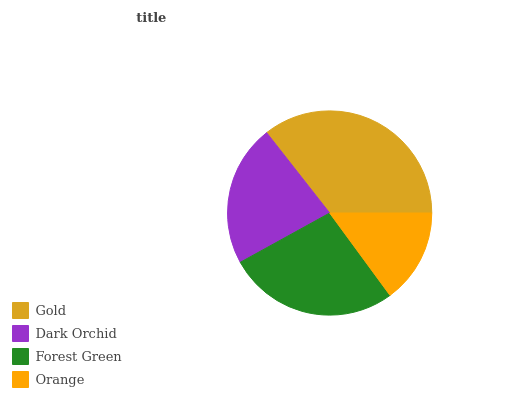Is Orange the minimum?
Answer yes or no. Yes. Is Gold the maximum?
Answer yes or no. Yes. Is Dark Orchid the minimum?
Answer yes or no. No. Is Dark Orchid the maximum?
Answer yes or no. No. Is Gold greater than Dark Orchid?
Answer yes or no. Yes. Is Dark Orchid less than Gold?
Answer yes or no. Yes. Is Dark Orchid greater than Gold?
Answer yes or no. No. Is Gold less than Dark Orchid?
Answer yes or no. No. Is Forest Green the high median?
Answer yes or no. Yes. Is Dark Orchid the low median?
Answer yes or no. Yes. Is Gold the high median?
Answer yes or no. No. Is Orange the low median?
Answer yes or no. No. 